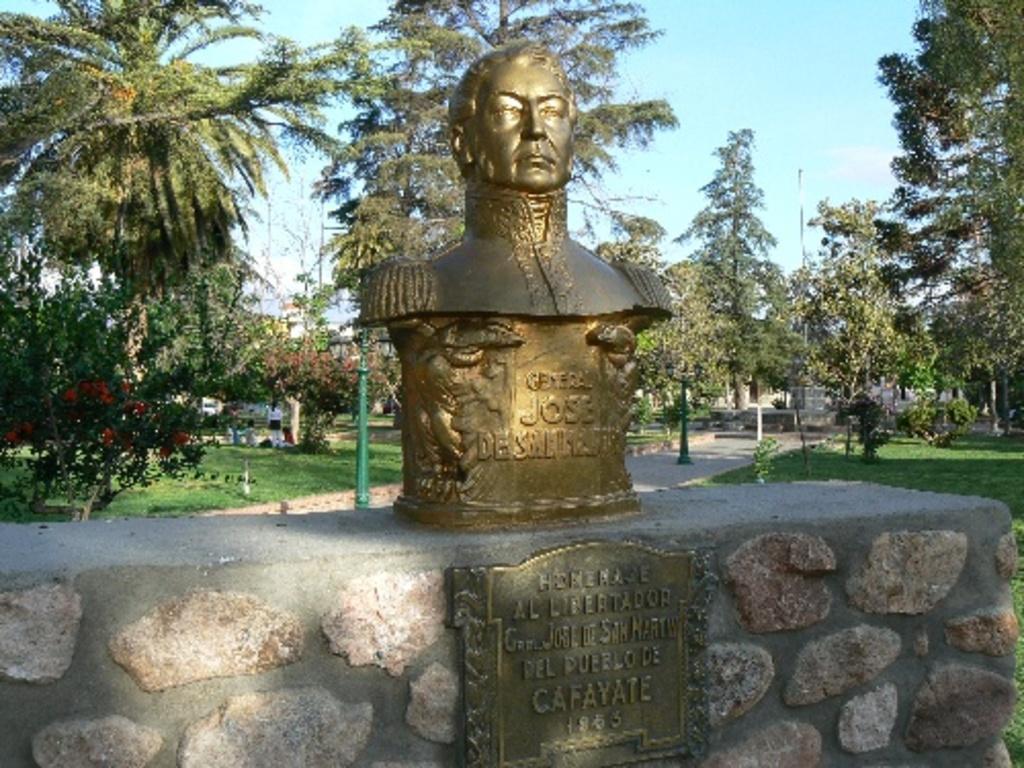In one or two sentences, can you explain what this image depicts? In front of the image there is a sculpture on the rock wall with some text on it, behind that there is a pavement, behind the pavement there are a few people on the surface. In the background of the image there are metal rods, trees and buildings. 